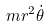Convert formula to latex. <formula><loc_0><loc_0><loc_500><loc_500>m r ^ { 2 } \dot { \theta }</formula> 